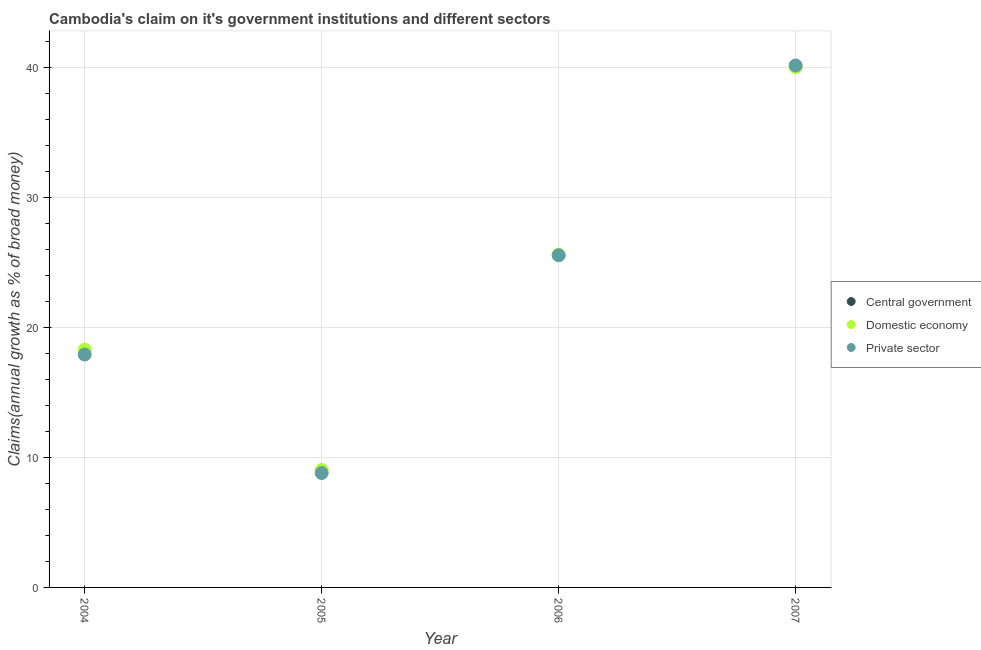How many different coloured dotlines are there?
Ensure brevity in your answer.  2. Is the number of dotlines equal to the number of legend labels?
Provide a short and direct response. No. What is the percentage of claim on the central government in 2004?
Your answer should be compact. 0. Across all years, what is the maximum percentage of claim on the private sector?
Your answer should be very brief. 40.15. Across all years, what is the minimum percentage of claim on the domestic economy?
Keep it short and to the point. 9.03. What is the total percentage of claim on the central government in the graph?
Keep it short and to the point. 0. What is the difference between the percentage of claim on the domestic economy in 2004 and that in 2006?
Your answer should be very brief. -7.3. What is the difference between the percentage of claim on the private sector in 2005 and the percentage of claim on the central government in 2004?
Give a very brief answer. 8.8. What is the average percentage of claim on the domestic economy per year?
Offer a terse response. 23.24. In the year 2007, what is the difference between the percentage of claim on the private sector and percentage of claim on the domestic economy?
Your answer should be compact. 0.13. What is the ratio of the percentage of claim on the domestic economy in 2004 to that in 2007?
Your response must be concise. 0.46. Is the percentage of claim on the domestic economy in 2004 less than that in 2006?
Your response must be concise. Yes. What is the difference between the highest and the second highest percentage of claim on the private sector?
Ensure brevity in your answer.  14.6. What is the difference between the highest and the lowest percentage of claim on the private sector?
Offer a terse response. 31.35. Is the sum of the percentage of claim on the domestic economy in 2004 and 2007 greater than the maximum percentage of claim on the private sector across all years?
Your answer should be very brief. Yes. Is the percentage of claim on the domestic economy strictly greater than the percentage of claim on the private sector over the years?
Ensure brevity in your answer.  No. How many years are there in the graph?
Keep it short and to the point. 4. What is the difference between two consecutive major ticks on the Y-axis?
Offer a terse response. 10. Does the graph contain any zero values?
Your answer should be very brief. Yes. Does the graph contain grids?
Provide a succinct answer. Yes. Where does the legend appear in the graph?
Offer a terse response. Center right. How are the legend labels stacked?
Keep it short and to the point. Vertical. What is the title of the graph?
Offer a terse response. Cambodia's claim on it's government institutions and different sectors. Does "Transport equipments" appear as one of the legend labels in the graph?
Provide a succinct answer. No. What is the label or title of the X-axis?
Your response must be concise. Year. What is the label or title of the Y-axis?
Give a very brief answer. Claims(annual growth as % of broad money). What is the Claims(annual growth as % of broad money) of Central government in 2004?
Provide a succinct answer. 0. What is the Claims(annual growth as % of broad money) of Domestic economy in 2004?
Your response must be concise. 18.29. What is the Claims(annual growth as % of broad money) of Private sector in 2004?
Offer a terse response. 17.92. What is the Claims(annual growth as % of broad money) of Central government in 2005?
Offer a very short reply. 0. What is the Claims(annual growth as % of broad money) of Domestic economy in 2005?
Give a very brief answer. 9.03. What is the Claims(annual growth as % of broad money) of Private sector in 2005?
Keep it short and to the point. 8.8. What is the Claims(annual growth as % of broad money) of Domestic economy in 2006?
Your response must be concise. 25.6. What is the Claims(annual growth as % of broad money) in Private sector in 2006?
Keep it short and to the point. 25.55. What is the Claims(annual growth as % of broad money) in Central government in 2007?
Give a very brief answer. 0. What is the Claims(annual growth as % of broad money) of Domestic economy in 2007?
Provide a short and direct response. 40.02. What is the Claims(annual growth as % of broad money) in Private sector in 2007?
Keep it short and to the point. 40.15. Across all years, what is the maximum Claims(annual growth as % of broad money) of Domestic economy?
Keep it short and to the point. 40.02. Across all years, what is the maximum Claims(annual growth as % of broad money) of Private sector?
Provide a succinct answer. 40.15. Across all years, what is the minimum Claims(annual growth as % of broad money) of Domestic economy?
Your answer should be very brief. 9.03. Across all years, what is the minimum Claims(annual growth as % of broad money) of Private sector?
Make the answer very short. 8.8. What is the total Claims(annual growth as % of broad money) of Domestic economy in the graph?
Keep it short and to the point. 92.95. What is the total Claims(annual growth as % of broad money) of Private sector in the graph?
Provide a short and direct response. 92.41. What is the difference between the Claims(annual growth as % of broad money) in Domestic economy in 2004 and that in 2005?
Provide a succinct answer. 9.26. What is the difference between the Claims(annual growth as % of broad money) of Private sector in 2004 and that in 2005?
Give a very brief answer. 9.12. What is the difference between the Claims(annual growth as % of broad money) of Domestic economy in 2004 and that in 2006?
Provide a short and direct response. -7.3. What is the difference between the Claims(annual growth as % of broad money) of Private sector in 2004 and that in 2006?
Provide a succinct answer. -7.63. What is the difference between the Claims(annual growth as % of broad money) of Domestic economy in 2004 and that in 2007?
Your answer should be very brief. -21.73. What is the difference between the Claims(annual growth as % of broad money) in Private sector in 2004 and that in 2007?
Offer a very short reply. -22.23. What is the difference between the Claims(annual growth as % of broad money) of Domestic economy in 2005 and that in 2006?
Your answer should be very brief. -16.56. What is the difference between the Claims(annual growth as % of broad money) of Private sector in 2005 and that in 2006?
Provide a succinct answer. -16.75. What is the difference between the Claims(annual growth as % of broad money) in Domestic economy in 2005 and that in 2007?
Ensure brevity in your answer.  -30.99. What is the difference between the Claims(annual growth as % of broad money) in Private sector in 2005 and that in 2007?
Offer a terse response. -31.35. What is the difference between the Claims(annual growth as % of broad money) of Domestic economy in 2006 and that in 2007?
Offer a terse response. -14.43. What is the difference between the Claims(annual growth as % of broad money) of Private sector in 2006 and that in 2007?
Ensure brevity in your answer.  -14.6. What is the difference between the Claims(annual growth as % of broad money) of Domestic economy in 2004 and the Claims(annual growth as % of broad money) of Private sector in 2005?
Your response must be concise. 9.49. What is the difference between the Claims(annual growth as % of broad money) in Domestic economy in 2004 and the Claims(annual growth as % of broad money) in Private sector in 2006?
Offer a very short reply. -7.26. What is the difference between the Claims(annual growth as % of broad money) of Domestic economy in 2004 and the Claims(annual growth as % of broad money) of Private sector in 2007?
Give a very brief answer. -21.86. What is the difference between the Claims(annual growth as % of broad money) of Domestic economy in 2005 and the Claims(annual growth as % of broad money) of Private sector in 2006?
Provide a succinct answer. -16.51. What is the difference between the Claims(annual growth as % of broad money) of Domestic economy in 2005 and the Claims(annual growth as % of broad money) of Private sector in 2007?
Offer a very short reply. -31.11. What is the difference between the Claims(annual growth as % of broad money) of Domestic economy in 2006 and the Claims(annual growth as % of broad money) of Private sector in 2007?
Your response must be concise. -14.55. What is the average Claims(annual growth as % of broad money) of Central government per year?
Provide a succinct answer. 0. What is the average Claims(annual growth as % of broad money) in Domestic economy per year?
Keep it short and to the point. 23.24. What is the average Claims(annual growth as % of broad money) of Private sector per year?
Your response must be concise. 23.1. In the year 2004, what is the difference between the Claims(annual growth as % of broad money) of Domestic economy and Claims(annual growth as % of broad money) of Private sector?
Keep it short and to the point. 0.37. In the year 2005, what is the difference between the Claims(annual growth as % of broad money) in Domestic economy and Claims(annual growth as % of broad money) in Private sector?
Ensure brevity in your answer.  0.24. In the year 2006, what is the difference between the Claims(annual growth as % of broad money) of Domestic economy and Claims(annual growth as % of broad money) of Private sector?
Offer a terse response. 0.05. In the year 2007, what is the difference between the Claims(annual growth as % of broad money) in Domestic economy and Claims(annual growth as % of broad money) in Private sector?
Make the answer very short. -0.13. What is the ratio of the Claims(annual growth as % of broad money) in Domestic economy in 2004 to that in 2005?
Your response must be concise. 2.02. What is the ratio of the Claims(annual growth as % of broad money) of Private sector in 2004 to that in 2005?
Offer a terse response. 2.04. What is the ratio of the Claims(annual growth as % of broad money) in Domestic economy in 2004 to that in 2006?
Offer a terse response. 0.71. What is the ratio of the Claims(annual growth as % of broad money) in Private sector in 2004 to that in 2006?
Offer a very short reply. 0.7. What is the ratio of the Claims(annual growth as % of broad money) in Domestic economy in 2004 to that in 2007?
Your response must be concise. 0.46. What is the ratio of the Claims(annual growth as % of broad money) in Private sector in 2004 to that in 2007?
Your answer should be very brief. 0.45. What is the ratio of the Claims(annual growth as % of broad money) in Domestic economy in 2005 to that in 2006?
Your answer should be very brief. 0.35. What is the ratio of the Claims(annual growth as % of broad money) in Private sector in 2005 to that in 2006?
Provide a short and direct response. 0.34. What is the ratio of the Claims(annual growth as % of broad money) of Domestic economy in 2005 to that in 2007?
Offer a terse response. 0.23. What is the ratio of the Claims(annual growth as % of broad money) of Private sector in 2005 to that in 2007?
Keep it short and to the point. 0.22. What is the ratio of the Claims(annual growth as % of broad money) of Domestic economy in 2006 to that in 2007?
Keep it short and to the point. 0.64. What is the ratio of the Claims(annual growth as % of broad money) of Private sector in 2006 to that in 2007?
Your response must be concise. 0.64. What is the difference between the highest and the second highest Claims(annual growth as % of broad money) of Domestic economy?
Provide a succinct answer. 14.43. What is the difference between the highest and the second highest Claims(annual growth as % of broad money) of Private sector?
Offer a terse response. 14.6. What is the difference between the highest and the lowest Claims(annual growth as % of broad money) in Domestic economy?
Your answer should be compact. 30.99. What is the difference between the highest and the lowest Claims(annual growth as % of broad money) in Private sector?
Offer a terse response. 31.35. 